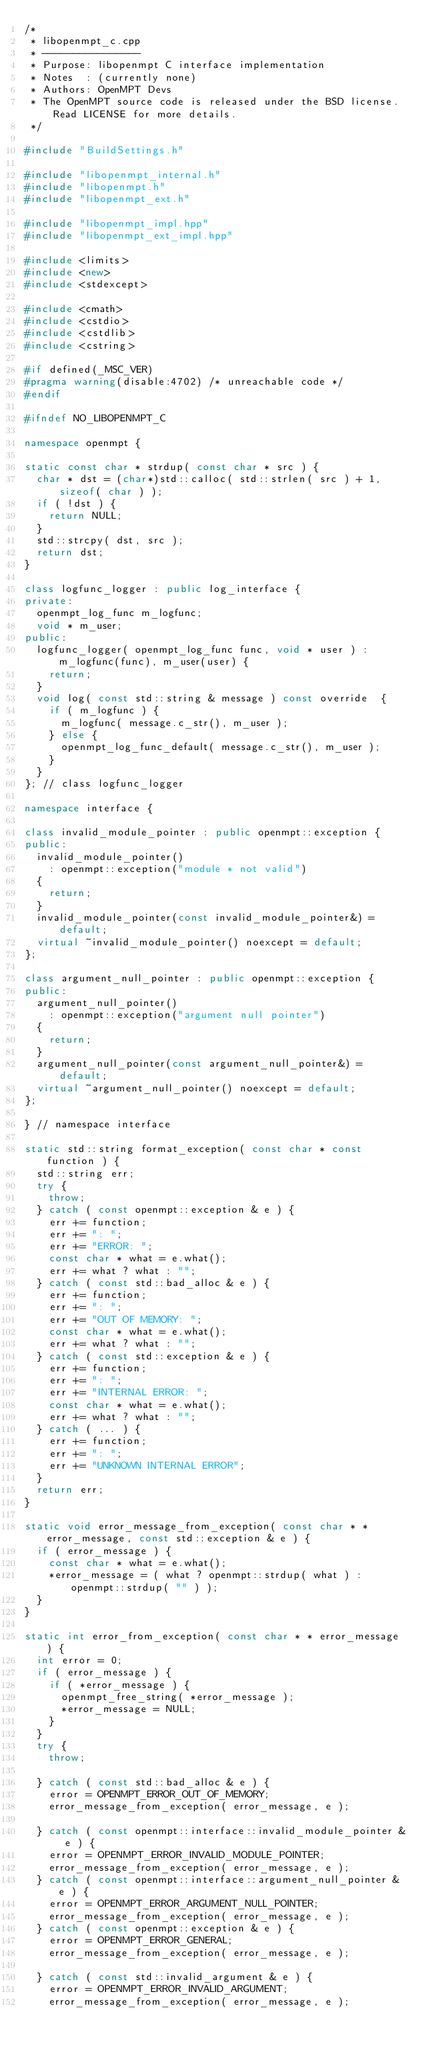<code> <loc_0><loc_0><loc_500><loc_500><_C++_>/*
 * libopenmpt_c.cpp
 * ----------------
 * Purpose: libopenmpt C interface implementation
 * Notes  : (currently none)
 * Authors: OpenMPT Devs
 * The OpenMPT source code is released under the BSD license. Read LICENSE for more details.
 */

#include "BuildSettings.h"

#include "libopenmpt_internal.h"
#include "libopenmpt.h"
#include "libopenmpt_ext.h"

#include "libopenmpt_impl.hpp"
#include "libopenmpt_ext_impl.hpp"

#include <limits>
#include <new>
#include <stdexcept>

#include <cmath>
#include <cstdio>
#include <cstdlib>
#include <cstring>

#if defined(_MSC_VER)
#pragma warning(disable:4702) /* unreachable code */
#endif

#ifndef NO_LIBOPENMPT_C

namespace openmpt {

static const char * strdup( const char * src ) {
	char * dst = (char*)std::calloc( std::strlen( src ) + 1, sizeof( char ) );
	if ( !dst ) {
		return NULL;
	}
	std::strcpy( dst, src );
	return dst;
}

class logfunc_logger : public log_interface {
private:
	openmpt_log_func m_logfunc;
	void * m_user;
public:
	logfunc_logger( openmpt_log_func func, void * user ) : m_logfunc(func), m_user(user) {
		return;
	}
	void log( const std::string & message ) const override  {
		if ( m_logfunc ) {
			m_logfunc( message.c_str(), m_user );
		} else {
			openmpt_log_func_default( message.c_str(), m_user );
		}
	}
}; // class logfunc_logger

namespace interface {

class invalid_module_pointer : public openmpt::exception {
public:
	invalid_module_pointer()
		: openmpt::exception("module * not valid")
	{
		return;
	}
	invalid_module_pointer(const invalid_module_pointer&) = default;
	virtual ~invalid_module_pointer() noexcept = default;
};

class argument_null_pointer : public openmpt::exception {
public:
	argument_null_pointer()
		: openmpt::exception("argument null pointer")
	{
		return;
	}
	argument_null_pointer(const argument_null_pointer&) = default;
	virtual ~argument_null_pointer() noexcept = default;
};

} // namespace interface

static std::string format_exception( const char * const function ) {
	std::string err;
	try {
		throw;
	} catch ( const openmpt::exception & e ) {
		err += function;
		err += ": ";
		err += "ERROR: ";
		const char * what = e.what();
		err += what ? what : "";
	} catch ( const std::bad_alloc & e ) {
		err += function;
		err += ": ";
		err += "OUT OF MEMORY: ";
		const char * what = e.what();
		err += what ? what : "";
	} catch ( const std::exception & e ) {
		err += function;
		err += ": ";
		err += "INTERNAL ERROR: ";
		const char * what = e.what();
		err += what ? what : "";
	} catch ( ... ) {
		err += function;
		err += ": ";
		err += "UNKNOWN INTERNAL ERROR";
	}
	return err;
}

static void error_message_from_exception( const char * * error_message, const std::exception & e ) {
	if ( error_message ) {
		const char * what = e.what();
		*error_message = ( what ? openmpt::strdup( what ) : openmpt::strdup( "" ) );
	}
}

static int error_from_exception( const char * * error_message ) {
	int error = 0;
	if ( error_message ) {
		if ( *error_message ) {
			openmpt_free_string( *error_message );
			*error_message = NULL;
		}
	}
	try {
		throw;

	} catch ( const std::bad_alloc & e ) {
		error = OPENMPT_ERROR_OUT_OF_MEMORY;
		error_message_from_exception( error_message, e );

	} catch ( const openmpt::interface::invalid_module_pointer & e ) {
		error = OPENMPT_ERROR_INVALID_MODULE_POINTER;
		error_message_from_exception( error_message, e );
	} catch ( const openmpt::interface::argument_null_pointer & e ) {
		error = OPENMPT_ERROR_ARGUMENT_NULL_POINTER;
		error_message_from_exception( error_message, e );
	} catch ( const openmpt::exception & e ) {
		error = OPENMPT_ERROR_GENERAL;
		error_message_from_exception( error_message, e );

	} catch ( const std::invalid_argument & e ) {
		error = OPENMPT_ERROR_INVALID_ARGUMENT;
		error_message_from_exception( error_message, e );</code> 